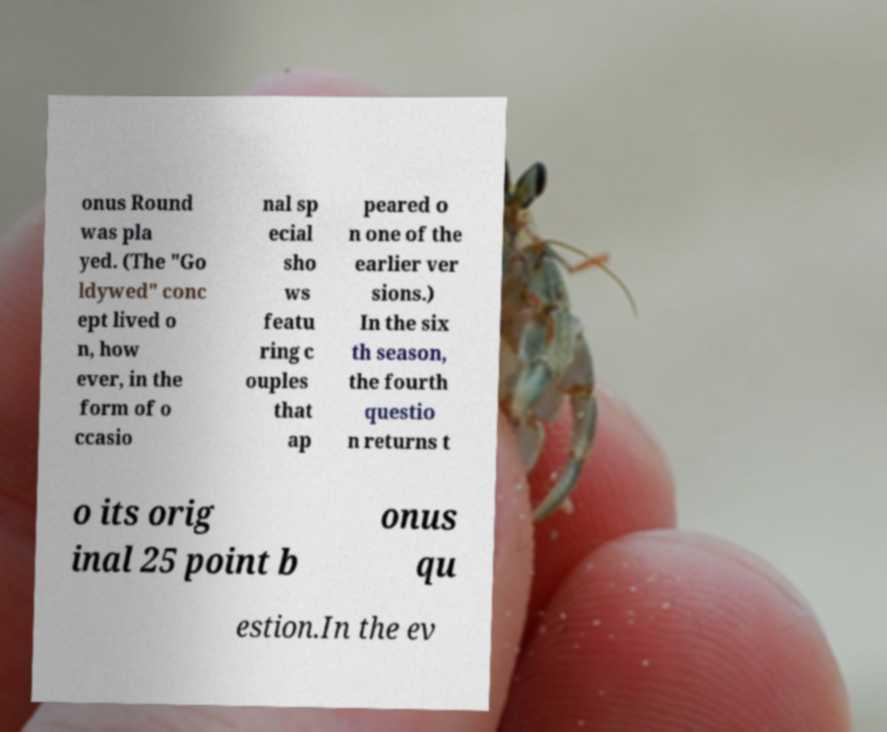There's text embedded in this image that I need extracted. Can you transcribe it verbatim? onus Round was pla yed. (The "Go ldywed" conc ept lived o n, how ever, in the form of o ccasio nal sp ecial sho ws featu ring c ouples that ap peared o n one of the earlier ver sions.) In the six th season, the fourth questio n returns t o its orig inal 25 point b onus qu estion.In the ev 